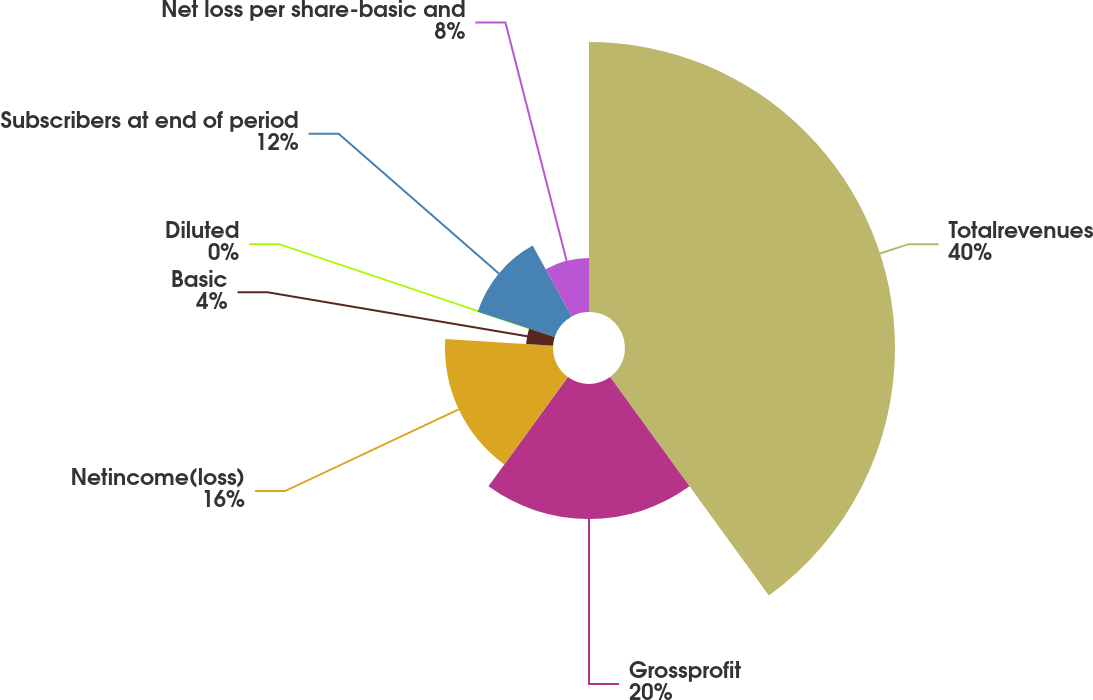Convert chart. <chart><loc_0><loc_0><loc_500><loc_500><pie_chart><fcel>Totalrevenues<fcel>Grossprofit<fcel>Netincome(loss)<fcel>Basic<fcel>Diluted<fcel>Subscribers at end of period<fcel>Net loss per share-basic and<nl><fcel>40.0%<fcel>20.0%<fcel>16.0%<fcel>4.0%<fcel>0.0%<fcel>12.0%<fcel>8.0%<nl></chart> 